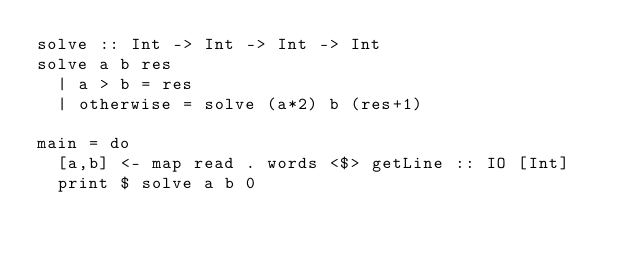Convert code to text. <code><loc_0><loc_0><loc_500><loc_500><_Haskell_>solve :: Int -> Int -> Int -> Int
solve a b res
  | a > b = res
  | otherwise = solve (a*2) b (res+1)

main = do
  [a,b] <- map read . words <$> getLine :: IO [Int]
  print $ solve a b 0</code> 